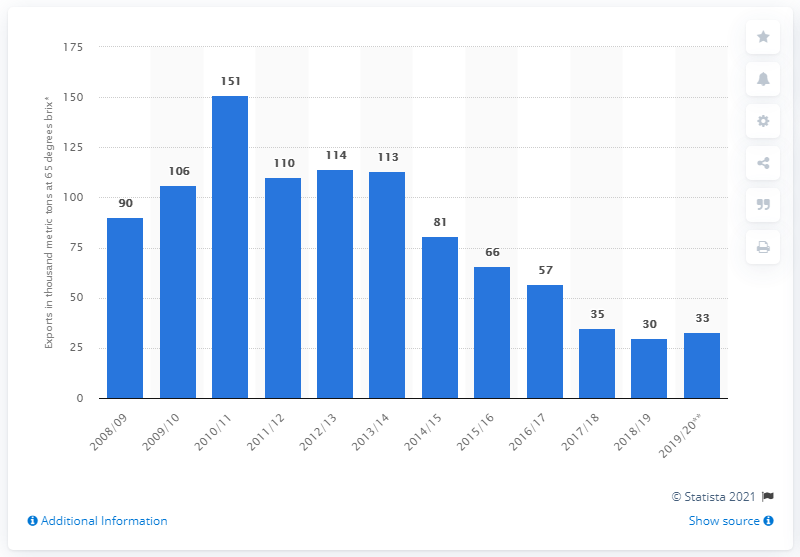Mention a couple of crucial points in this snapshot. The export of orange juice to the United States occurred in the year 2008/2009. 